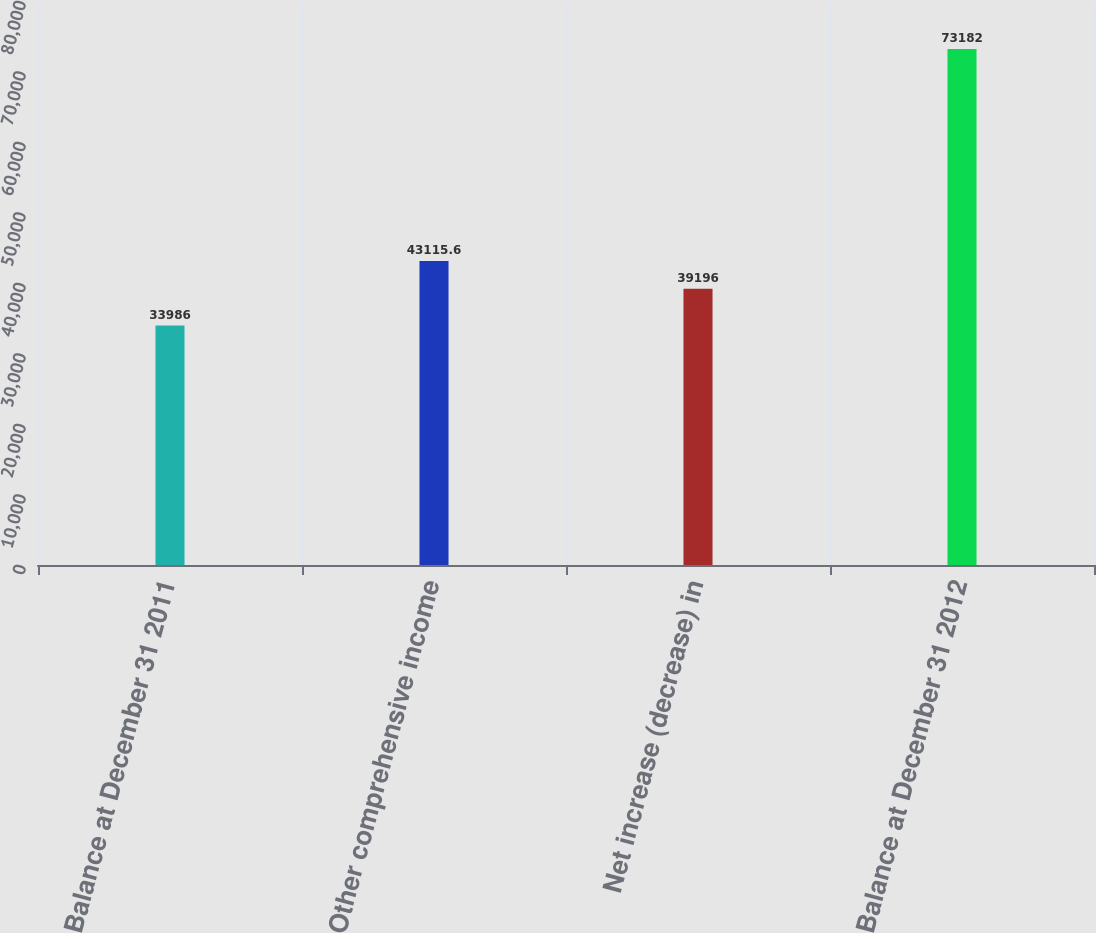Convert chart to OTSL. <chart><loc_0><loc_0><loc_500><loc_500><bar_chart><fcel>Balance at December 31 2011<fcel>Other comprehensive income<fcel>Net increase (decrease) in<fcel>Balance at December 31 2012<nl><fcel>33986<fcel>43115.6<fcel>39196<fcel>73182<nl></chart> 